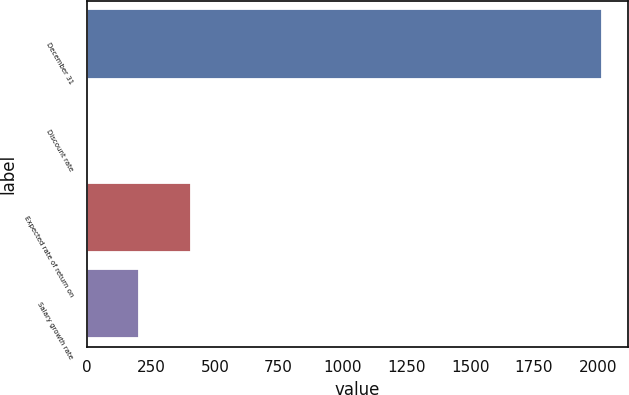<chart> <loc_0><loc_0><loc_500><loc_500><bar_chart><fcel>December 31<fcel>Discount rate<fcel>Expected rate of return on<fcel>Salary growth rate<nl><fcel>2016<fcel>2.8<fcel>405.44<fcel>204.12<nl></chart> 